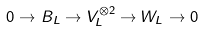Convert formula to latex. <formula><loc_0><loc_0><loc_500><loc_500>0 \to B _ { L } \to V _ { L } ^ { \otimes 2 } \to W _ { L } \to 0</formula> 